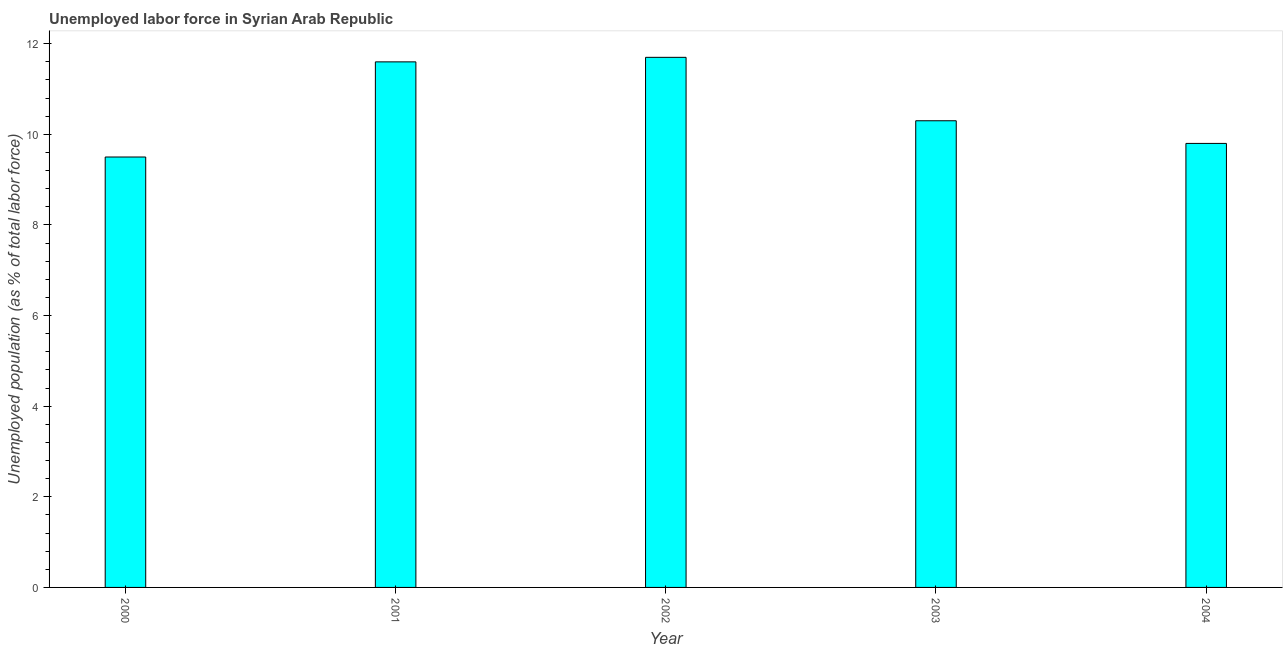Does the graph contain grids?
Offer a terse response. No. What is the title of the graph?
Give a very brief answer. Unemployed labor force in Syrian Arab Republic. What is the label or title of the X-axis?
Your response must be concise. Year. What is the label or title of the Y-axis?
Offer a terse response. Unemployed population (as % of total labor force). What is the total unemployed population in 2002?
Your answer should be compact. 11.7. Across all years, what is the maximum total unemployed population?
Your answer should be compact. 11.7. What is the sum of the total unemployed population?
Provide a short and direct response. 52.9. What is the average total unemployed population per year?
Give a very brief answer. 10.58. What is the median total unemployed population?
Make the answer very short. 10.3. Do a majority of the years between 2002 and 2001 (inclusive) have total unemployed population greater than 10.8 %?
Make the answer very short. No. What is the ratio of the total unemployed population in 2001 to that in 2003?
Provide a succinct answer. 1.13. Is the total unemployed population in 2001 less than that in 2003?
Ensure brevity in your answer.  No. Is the sum of the total unemployed population in 2000 and 2002 greater than the maximum total unemployed population across all years?
Offer a very short reply. Yes. What is the difference between the highest and the lowest total unemployed population?
Offer a very short reply. 2.2. In how many years, is the total unemployed population greater than the average total unemployed population taken over all years?
Offer a very short reply. 2. How many years are there in the graph?
Ensure brevity in your answer.  5. Are the values on the major ticks of Y-axis written in scientific E-notation?
Provide a succinct answer. No. What is the Unemployed population (as % of total labor force) of 2000?
Keep it short and to the point. 9.5. What is the Unemployed population (as % of total labor force) of 2001?
Your answer should be compact. 11.6. What is the Unemployed population (as % of total labor force) in 2002?
Give a very brief answer. 11.7. What is the Unemployed population (as % of total labor force) in 2003?
Provide a short and direct response. 10.3. What is the Unemployed population (as % of total labor force) of 2004?
Your answer should be very brief. 9.8. What is the difference between the Unemployed population (as % of total labor force) in 2000 and 2001?
Offer a very short reply. -2.1. What is the difference between the Unemployed population (as % of total labor force) in 2000 and 2002?
Your answer should be very brief. -2.2. What is the difference between the Unemployed population (as % of total labor force) in 2002 and 2004?
Ensure brevity in your answer.  1.9. What is the difference between the Unemployed population (as % of total labor force) in 2003 and 2004?
Provide a short and direct response. 0.5. What is the ratio of the Unemployed population (as % of total labor force) in 2000 to that in 2001?
Offer a terse response. 0.82. What is the ratio of the Unemployed population (as % of total labor force) in 2000 to that in 2002?
Provide a short and direct response. 0.81. What is the ratio of the Unemployed population (as % of total labor force) in 2000 to that in 2003?
Provide a short and direct response. 0.92. What is the ratio of the Unemployed population (as % of total labor force) in 2001 to that in 2002?
Provide a short and direct response. 0.99. What is the ratio of the Unemployed population (as % of total labor force) in 2001 to that in 2003?
Ensure brevity in your answer.  1.13. What is the ratio of the Unemployed population (as % of total labor force) in 2001 to that in 2004?
Offer a terse response. 1.18. What is the ratio of the Unemployed population (as % of total labor force) in 2002 to that in 2003?
Provide a succinct answer. 1.14. What is the ratio of the Unemployed population (as % of total labor force) in 2002 to that in 2004?
Offer a terse response. 1.19. What is the ratio of the Unemployed population (as % of total labor force) in 2003 to that in 2004?
Your answer should be very brief. 1.05. 